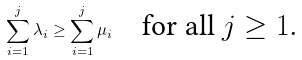Convert formula to latex. <formula><loc_0><loc_0><loc_500><loc_500>\sum _ { i = 1 } ^ { j } \lambda _ { i } \geq \sum _ { i = 1 } ^ { j } \mu _ { i } \quad \text {for all $j\geq 1$.}</formula> 